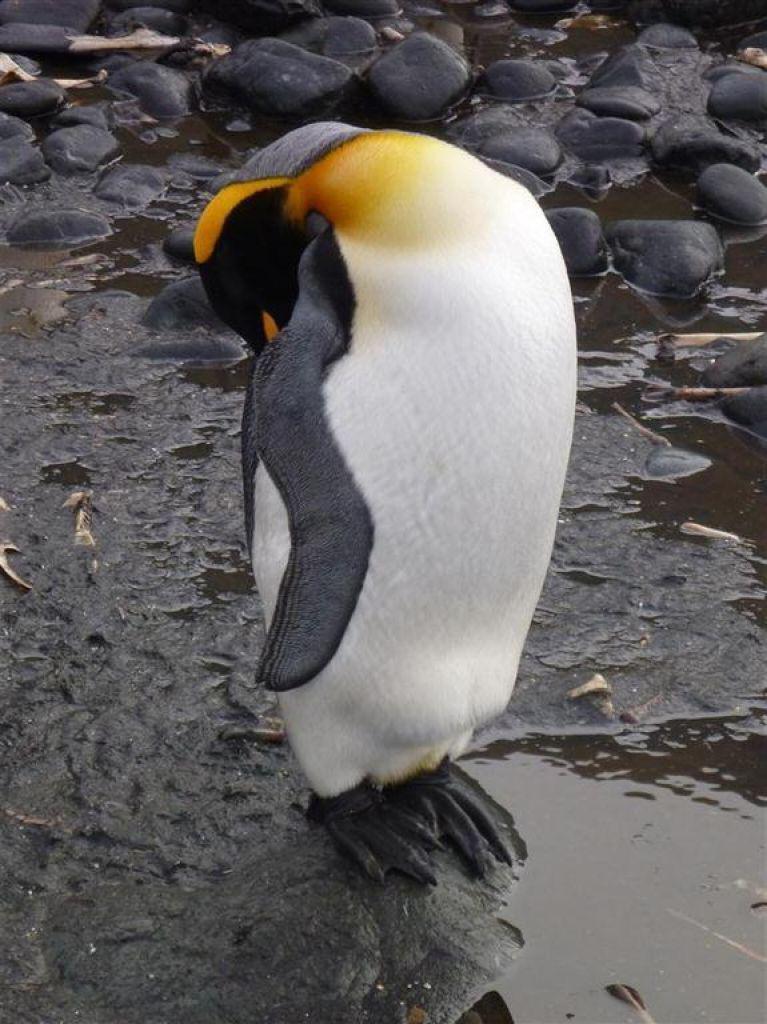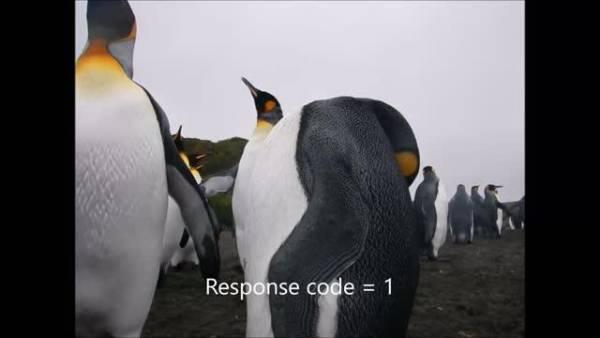The first image is the image on the left, the second image is the image on the right. Assess this claim about the two images: "One image has a penguin surrounded by grass and rocks.". Correct or not? Answer yes or no. No. The first image is the image on the left, the second image is the image on the right. Analyze the images presented: Is the assertion "At least one of the images includes a penguin that is lying down." valid? Answer yes or no. No. 